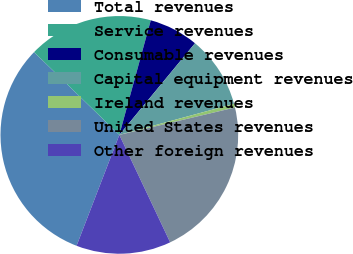Convert chart. <chart><loc_0><loc_0><loc_500><loc_500><pie_chart><fcel>Total revenues<fcel>Service revenues<fcel>Consumable revenues<fcel>Capital equipment revenues<fcel>Ireland revenues<fcel>United States revenues<fcel>Other foreign revenues<nl><fcel>31.4%<fcel>17.0%<fcel>6.72%<fcel>9.8%<fcel>0.51%<fcel>21.67%<fcel>12.89%<nl></chart> 